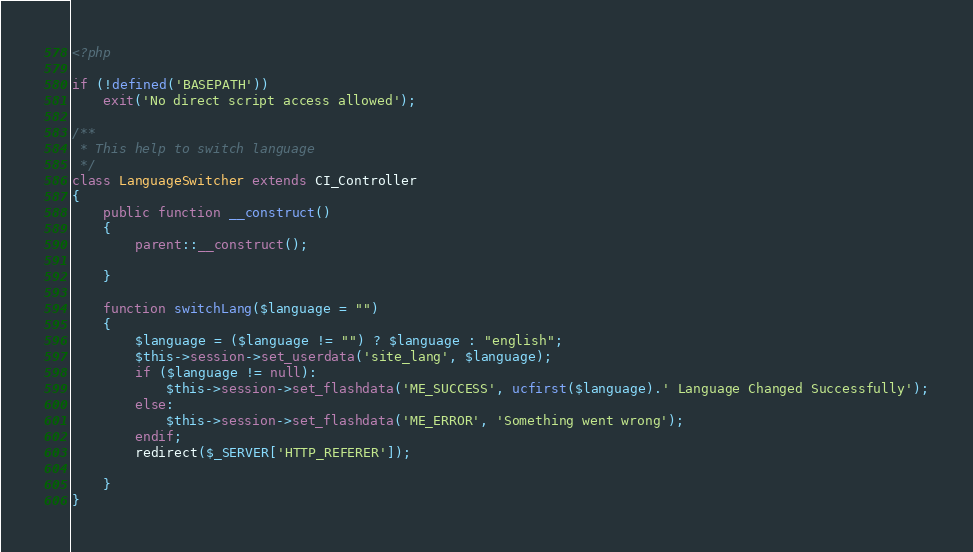Convert code to text. <code><loc_0><loc_0><loc_500><loc_500><_PHP_><?php

if (!defined('BASEPATH'))
    exit('No direct script access allowed');

/**
 * This help to switch language
 */
class LanguageSwitcher extends CI_Controller
{
    public function __construct()
    {
        parent::__construct();

    }

    function switchLang($language = "")
    {
        $language = ($language != "") ? $language : "english";
        $this->session->set_userdata('site_lang', $language);
        if ($language != null):
            $this->session->set_flashdata('ME_SUCCESS', ucfirst($language).' Language Changed Successfully');
        else:
            $this->session->set_flashdata('ME_ERROR', 'Something went wrong');
        endif;
        redirect($_SERVER['HTTP_REFERER']);

    }
}</code> 